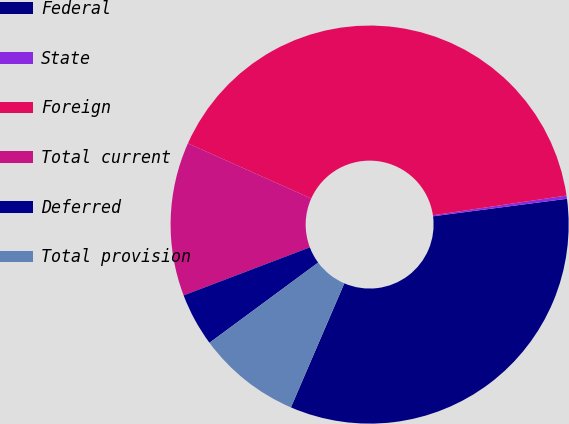<chart> <loc_0><loc_0><loc_500><loc_500><pie_chart><fcel>Federal<fcel>State<fcel>Foreign<fcel>Total current<fcel>Deferred<fcel>Total provision<nl><fcel>33.54%<fcel>0.26%<fcel>40.98%<fcel>12.48%<fcel>4.33%<fcel>8.41%<nl></chart> 